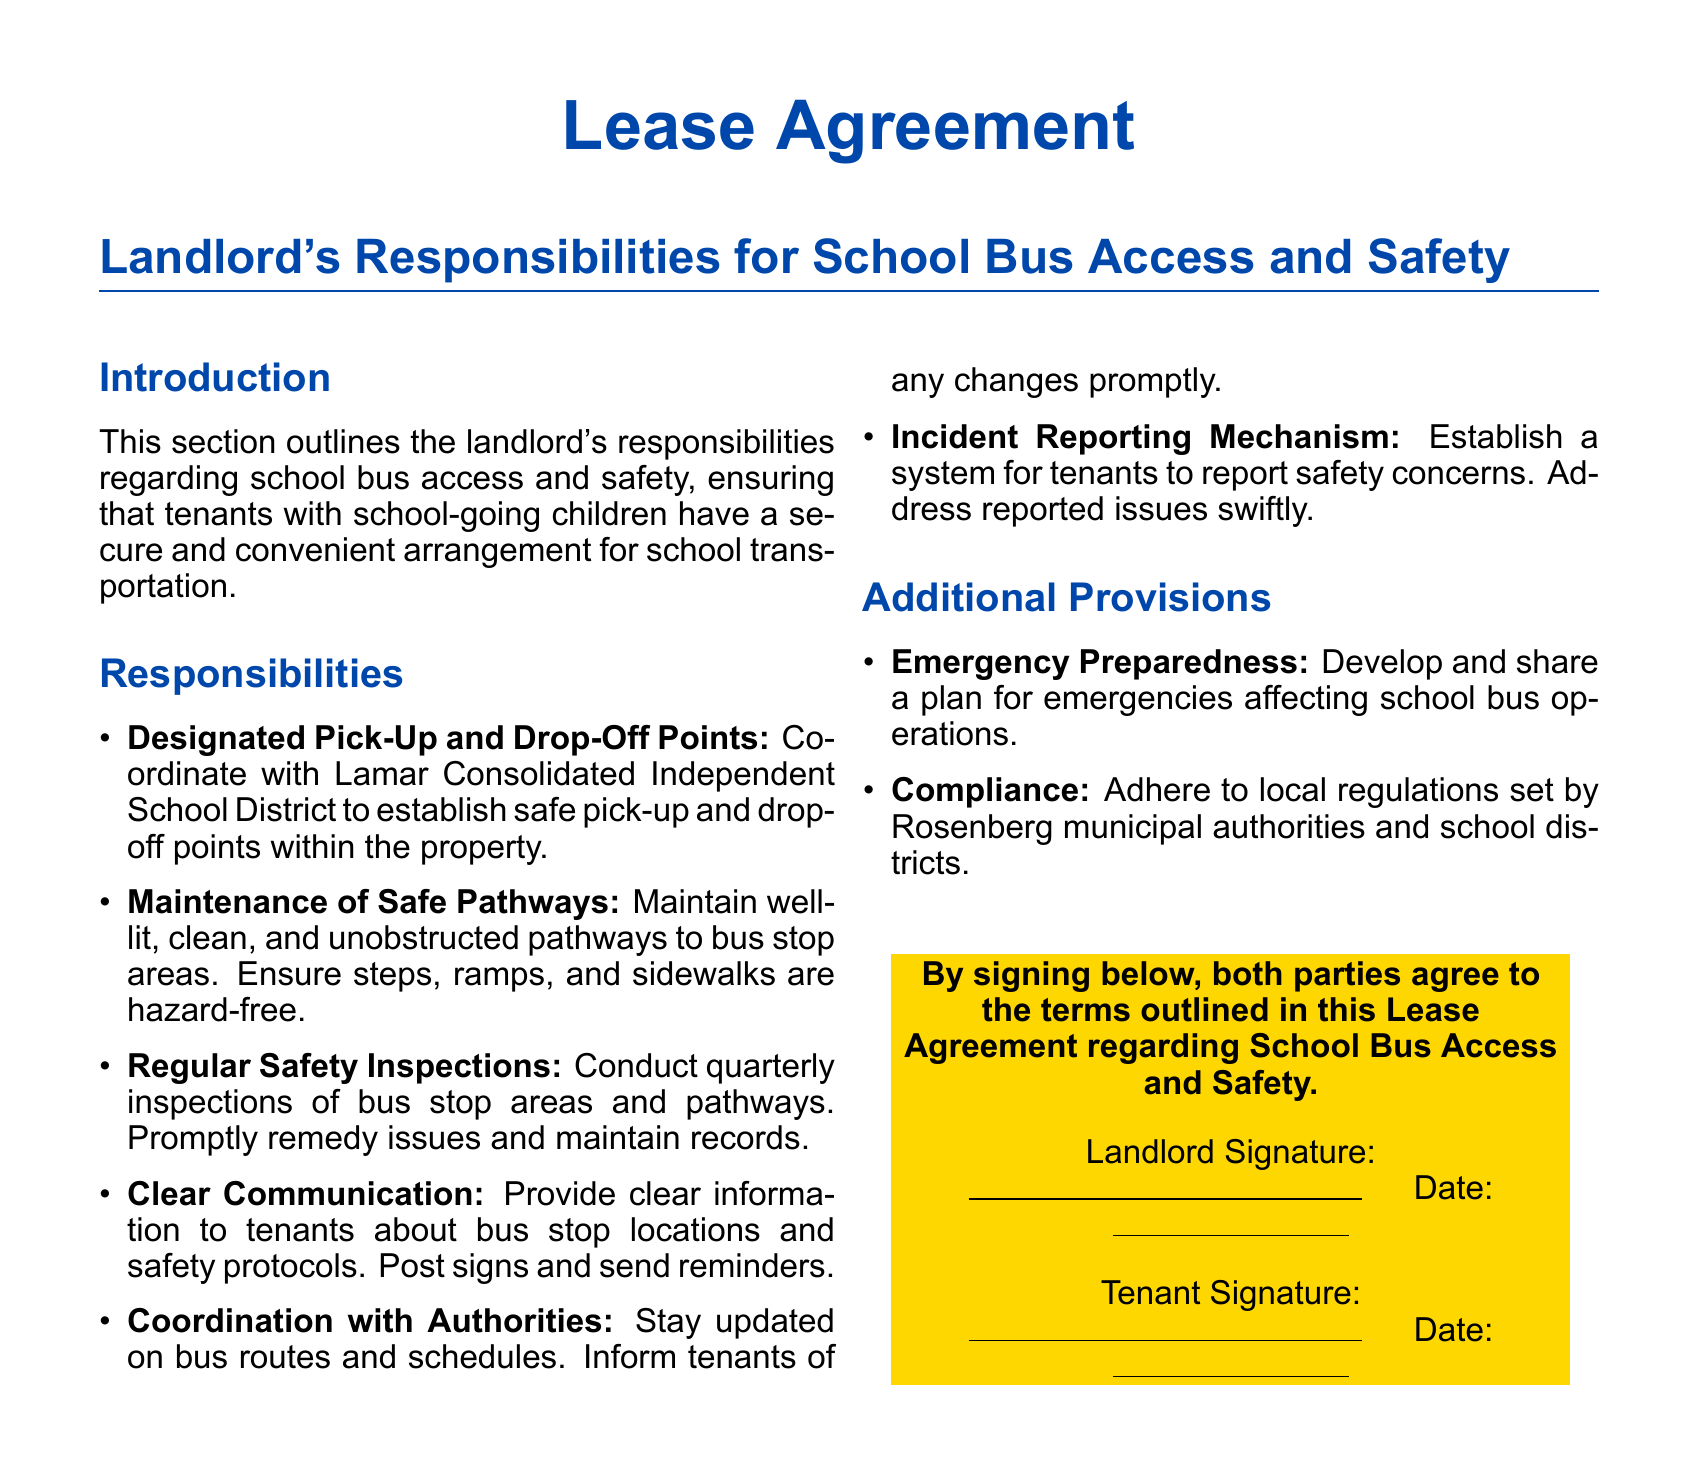what are the designated points for school buses? The landlord is responsible for coordinating with the Lamar Consolidated Independent School District to establish safe pick-up and drop-off points within the property.
Answer: safe pick-up and drop-off points how often are safety inspections conducted? The document specifies that safety inspections of bus stop areas and pathways are conducted quarterly.
Answer: quarterly what type of pathways should the landlord maintain? The landlord must ensure that pathways to bus stop areas are well-lit, clean, and unobstructed.
Answer: well-lit, clean, and unobstructed pathways what mechanism should be established for safety concerns? The lease outlines the establishment of a system for tenants to report safety concerns.
Answer: incident reporting mechanism who should be informed about changes in bus routes? The landlord is responsible for informing tenants of any changes in bus routes and schedules promptly.
Answer: tenants what is included in the emergency preparedness provision? The landlord must develop and share a plan for emergencies affecting school bus operations.
Answer: plan for emergencies what color is the box containing the agreement statement? The document features a color box with a specific hue for the agreement statement.
Answer: yellow what must the landlord do regarding local regulations? The landlord is required to adhere to local regulations set by Rosenberg municipal authorities and school districts.
Answer: comply with local regulations 